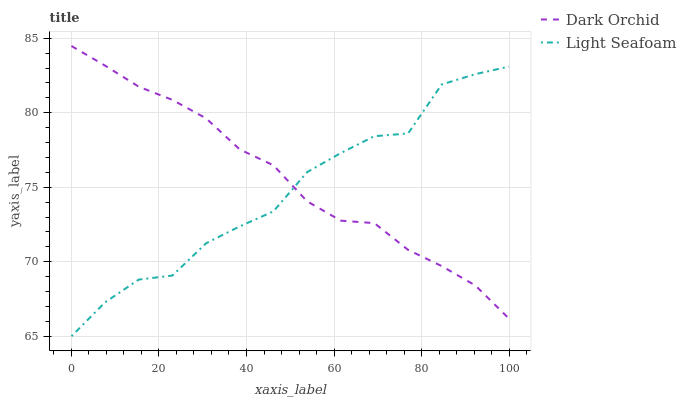Does Light Seafoam have the minimum area under the curve?
Answer yes or no. Yes. Does Dark Orchid have the maximum area under the curve?
Answer yes or no. Yes. Does Dark Orchid have the minimum area under the curve?
Answer yes or no. No. Is Dark Orchid the smoothest?
Answer yes or no. Yes. Is Light Seafoam the roughest?
Answer yes or no. Yes. Is Dark Orchid the roughest?
Answer yes or no. No. Does Light Seafoam have the lowest value?
Answer yes or no. Yes. Does Dark Orchid have the lowest value?
Answer yes or no. No. Does Dark Orchid have the highest value?
Answer yes or no. Yes. Does Light Seafoam intersect Dark Orchid?
Answer yes or no. Yes. Is Light Seafoam less than Dark Orchid?
Answer yes or no. No. Is Light Seafoam greater than Dark Orchid?
Answer yes or no. No. 